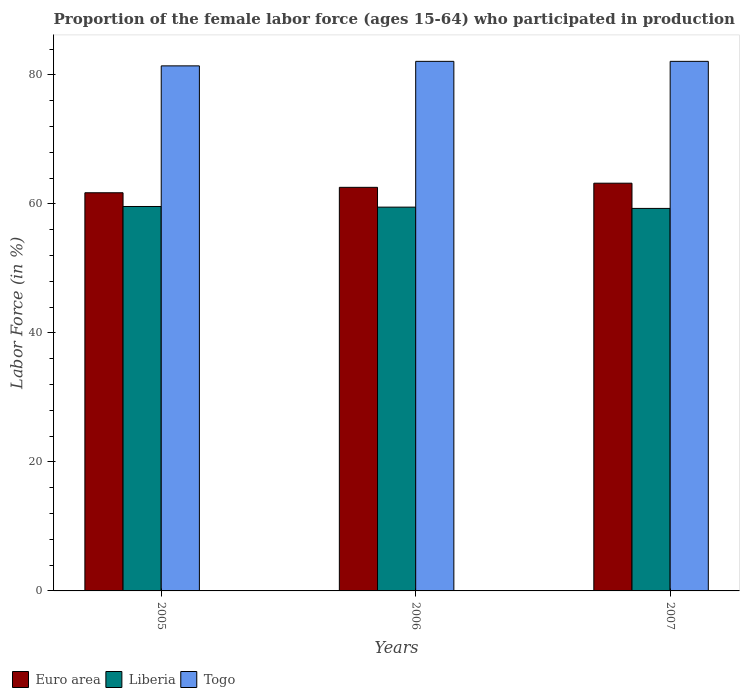How many different coloured bars are there?
Offer a very short reply. 3. How many groups of bars are there?
Your answer should be very brief. 3. Are the number of bars per tick equal to the number of legend labels?
Offer a terse response. Yes. Are the number of bars on each tick of the X-axis equal?
Give a very brief answer. Yes. What is the proportion of the female labor force who participated in production in Liberia in 2007?
Give a very brief answer. 59.3. Across all years, what is the maximum proportion of the female labor force who participated in production in Euro area?
Give a very brief answer. 63.21. Across all years, what is the minimum proportion of the female labor force who participated in production in Togo?
Provide a succinct answer. 81.4. In which year was the proportion of the female labor force who participated in production in Euro area maximum?
Ensure brevity in your answer.  2007. In which year was the proportion of the female labor force who participated in production in Euro area minimum?
Your answer should be very brief. 2005. What is the total proportion of the female labor force who participated in production in Euro area in the graph?
Provide a short and direct response. 187.51. What is the difference between the proportion of the female labor force who participated in production in Liberia in 2005 and that in 2007?
Provide a short and direct response. 0.3. What is the difference between the proportion of the female labor force who participated in production in Euro area in 2007 and the proportion of the female labor force who participated in production in Liberia in 2006?
Provide a short and direct response. 3.71. What is the average proportion of the female labor force who participated in production in Euro area per year?
Ensure brevity in your answer.  62.5. In the year 2007, what is the difference between the proportion of the female labor force who participated in production in Liberia and proportion of the female labor force who participated in production in Euro area?
Your answer should be very brief. -3.91. In how many years, is the proportion of the female labor force who participated in production in Liberia greater than 52 %?
Your response must be concise. 3. What is the ratio of the proportion of the female labor force who participated in production in Euro area in 2005 to that in 2007?
Keep it short and to the point. 0.98. Is the difference between the proportion of the female labor force who participated in production in Liberia in 2005 and 2007 greater than the difference between the proportion of the female labor force who participated in production in Euro area in 2005 and 2007?
Provide a succinct answer. Yes. What is the difference between the highest and the lowest proportion of the female labor force who participated in production in Euro area?
Offer a terse response. 1.48. Is the sum of the proportion of the female labor force who participated in production in Liberia in 2005 and 2006 greater than the maximum proportion of the female labor force who participated in production in Togo across all years?
Ensure brevity in your answer.  Yes. What does the 3rd bar from the left in 2005 represents?
Offer a terse response. Togo. Is it the case that in every year, the sum of the proportion of the female labor force who participated in production in Liberia and proportion of the female labor force who participated in production in Euro area is greater than the proportion of the female labor force who participated in production in Togo?
Provide a succinct answer. Yes. How many bars are there?
Ensure brevity in your answer.  9. Are the values on the major ticks of Y-axis written in scientific E-notation?
Provide a short and direct response. No. How many legend labels are there?
Ensure brevity in your answer.  3. How are the legend labels stacked?
Ensure brevity in your answer.  Horizontal. What is the title of the graph?
Make the answer very short. Proportion of the female labor force (ages 15-64) who participated in production. Does "Bahrain" appear as one of the legend labels in the graph?
Give a very brief answer. No. What is the label or title of the Y-axis?
Offer a very short reply. Labor Force (in %). What is the Labor Force (in %) in Euro area in 2005?
Your answer should be very brief. 61.73. What is the Labor Force (in %) in Liberia in 2005?
Make the answer very short. 59.6. What is the Labor Force (in %) in Togo in 2005?
Your response must be concise. 81.4. What is the Labor Force (in %) of Euro area in 2006?
Provide a short and direct response. 62.57. What is the Labor Force (in %) of Liberia in 2006?
Provide a succinct answer. 59.5. What is the Labor Force (in %) of Togo in 2006?
Give a very brief answer. 82.1. What is the Labor Force (in %) in Euro area in 2007?
Your answer should be compact. 63.21. What is the Labor Force (in %) of Liberia in 2007?
Offer a terse response. 59.3. What is the Labor Force (in %) of Togo in 2007?
Make the answer very short. 82.1. Across all years, what is the maximum Labor Force (in %) of Euro area?
Your response must be concise. 63.21. Across all years, what is the maximum Labor Force (in %) of Liberia?
Give a very brief answer. 59.6. Across all years, what is the maximum Labor Force (in %) in Togo?
Your answer should be compact. 82.1. Across all years, what is the minimum Labor Force (in %) of Euro area?
Offer a terse response. 61.73. Across all years, what is the minimum Labor Force (in %) in Liberia?
Provide a short and direct response. 59.3. Across all years, what is the minimum Labor Force (in %) of Togo?
Provide a succinct answer. 81.4. What is the total Labor Force (in %) in Euro area in the graph?
Provide a short and direct response. 187.51. What is the total Labor Force (in %) in Liberia in the graph?
Give a very brief answer. 178.4. What is the total Labor Force (in %) in Togo in the graph?
Ensure brevity in your answer.  245.6. What is the difference between the Labor Force (in %) of Euro area in 2005 and that in 2006?
Offer a terse response. -0.84. What is the difference between the Labor Force (in %) of Euro area in 2005 and that in 2007?
Your response must be concise. -1.48. What is the difference between the Labor Force (in %) in Euro area in 2006 and that in 2007?
Your response must be concise. -0.64. What is the difference between the Labor Force (in %) of Liberia in 2006 and that in 2007?
Your response must be concise. 0.2. What is the difference between the Labor Force (in %) in Togo in 2006 and that in 2007?
Give a very brief answer. 0. What is the difference between the Labor Force (in %) of Euro area in 2005 and the Labor Force (in %) of Liberia in 2006?
Ensure brevity in your answer.  2.23. What is the difference between the Labor Force (in %) of Euro area in 2005 and the Labor Force (in %) of Togo in 2006?
Your answer should be compact. -20.37. What is the difference between the Labor Force (in %) of Liberia in 2005 and the Labor Force (in %) of Togo in 2006?
Ensure brevity in your answer.  -22.5. What is the difference between the Labor Force (in %) of Euro area in 2005 and the Labor Force (in %) of Liberia in 2007?
Offer a very short reply. 2.43. What is the difference between the Labor Force (in %) of Euro area in 2005 and the Labor Force (in %) of Togo in 2007?
Your response must be concise. -20.37. What is the difference between the Labor Force (in %) of Liberia in 2005 and the Labor Force (in %) of Togo in 2007?
Give a very brief answer. -22.5. What is the difference between the Labor Force (in %) of Euro area in 2006 and the Labor Force (in %) of Liberia in 2007?
Provide a succinct answer. 3.27. What is the difference between the Labor Force (in %) in Euro area in 2006 and the Labor Force (in %) in Togo in 2007?
Your answer should be very brief. -19.53. What is the difference between the Labor Force (in %) in Liberia in 2006 and the Labor Force (in %) in Togo in 2007?
Your answer should be very brief. -22.6. What is the average Labor Force (in %) in Euro area per year?
Your response must be concise. 62.5. What is the average Labor Force (in %) in Liberia per year?
Give a very brief answer. 59.47. What is the average Labor Force (in %) of Togo per year?
Make the answer very short. 81.87. In the year 2005, what is the difference between the Labor Force (in %) of Euro area and Labor Force (in %) of Liberia?
Offer a terse response. 2.13. In the year 2005, what is the difference between the Labor Force (in %) of Euro area and Labor Force (in %) of Togo?
Your response must be concise. -19.67. In the year 2005, what is the difference between the Labor Force (in %) of Liberia and Labor Force (in %) of Togo?
Offer a terse response. -21.8. In the year 2006, what is the difference between the Labor Force (in %) of Euro area and Labor Force (in %) of Liberia?
Keep it short and to the point. 3.07. In the year 2006, what is the difference between the Labor Force (in %) of Euro area and Labor Force (in %) of Togo?
Provide a short and direct response. -19.53. In the year 2006, what is the difference between the Labor Force (in %) of Liberia and Labor Force (in %) of Togo?
Make the answer very short. -22.6. In the year 2007, what is the difference between the Labor Force (in %) in Euro area and Labor Force (in %) in Liberia?
Provide a short and direct response. 3.91. In the year 2007, what is the difference between the Labor Force (in %) of Euro area and Labor Force (in %) of Togo?
Provide a succinct answer. -18.89. In the year 2007, what is the difference between the Labor Force (in %) of Liberia and Labor Force (in %) of Togo?
Offer a very short reply. -22.8. What is the ratio of the Labor Force (in %) of Euro area in 2005 to that in 2006?
Offer a terse response. 0.99. What is the ratio of the Labor Force (in %) of Euro area in 2005 to that in 2007?
Your response must be concise. 0.98. What is the ratio of the Labor Force (in %) in Togo in 2005 to that in 2007?
Make the answer very short. 0.99. What is the ratio of the Labor Force (in %) of Togo in 2006 to that in 2007?
Keep it short and to the point. 1. What is the difference between the highest and the second highest Labor Force (in %) in Euro area?
Offer a terse response. 0.64. What is the difference between the highest and the second highest Labor Force (in %) of Liberia?
Your response must be concise. 0.1. What is the difference between the highest and the lowest Labor Force (in %) of Euro area?
Your response must be concise. 1.48. What is the difference between the highest and the lowest Labor Force (in %) in Liberia?
Offer a very short reply. 0.3. 